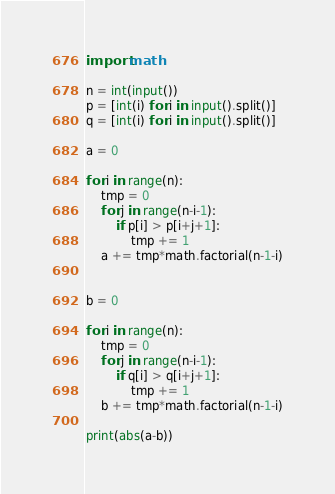Convert code to text. <code><loc_0><loc_0><loc_500><loc_500><_Python_>import math

n = int(input())
p = [int(i) for i in input().split()]
q = [int(i) for i in input().split()]

a = 0

for i in range(n):
    tmp = 0
    for j in range(n-i-1):
        if p[i] > p[i+j+1]:
            tmp += 1
    a += tmp*math.factorial(n-1-i)


b = 0

for i in range(n):
    tmp = 0
    for j in range(n-i-1):
        if q[i] > q[i+j+1]:
            tmp += 1
    b += tmp*math.factorial(n-1-i)
    
print(abs(a-b))</code> 